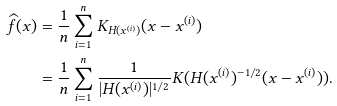Convert formula to latex. <formula><loc_0><loc_0><loc_500><loc_500>\widehat { f } ( { x } ) & = \frac { 1 } { n } \sum _ { i = 1 } ^ { n } K _ { { H } ( { x } ^ { ( i ) } ) } ( { x } - { x } ^ { ( i ) } ) \\ & = \frac { 1 } { n } \sum _ { i = 1 } ^ { n } \frac { 1 } { | { H } ( { x } ^ { ( i ) } ) | ^ { 1 / 2 } } K ( { H } ( { x } ^ { ( i ) } ) ^ { - 1 / 2 } ( { x } - { x } ^ { ( i ) } ) ) .</formula> 